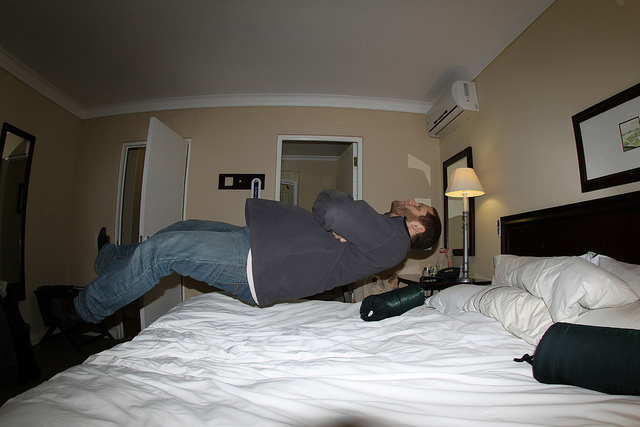The man here is posing to mimic what?
A. drunkenness
B. levitation
C. working out
D. insomnia The man in the image is creatively posing as if he is levitating. His alignment and position above the bed, along with the camera angle, create the illusion of him floating in mid-air, thus B. levitation is the appropriate answer. 